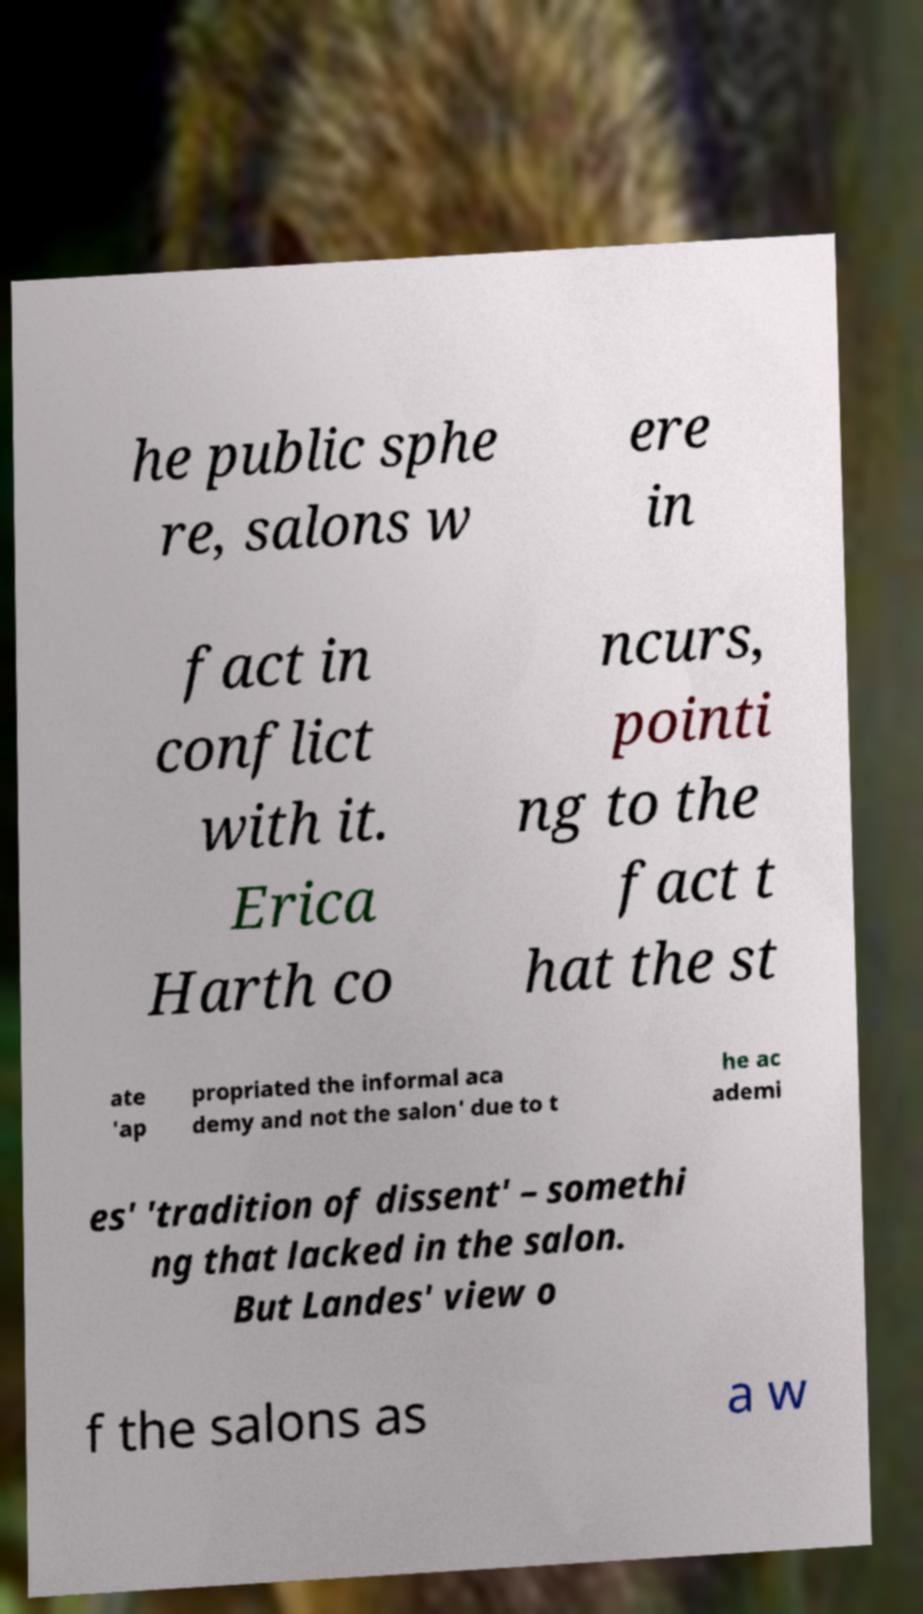Can you read and provide the text displayed in the image?This photo seems to have some interesting text. Can you extract and type it out for me? he public sphe re, salons w ere in fact in conflict with it. Erica Harth co ncurs, pointi ng to the fact t hat the st ate 'ap propriated the informal aca demy and not the salon' due to t he ac ademi es' 'tradition of dissent' – somethi ng that lacked in the salon. But Landes' view o f the salons as a w 